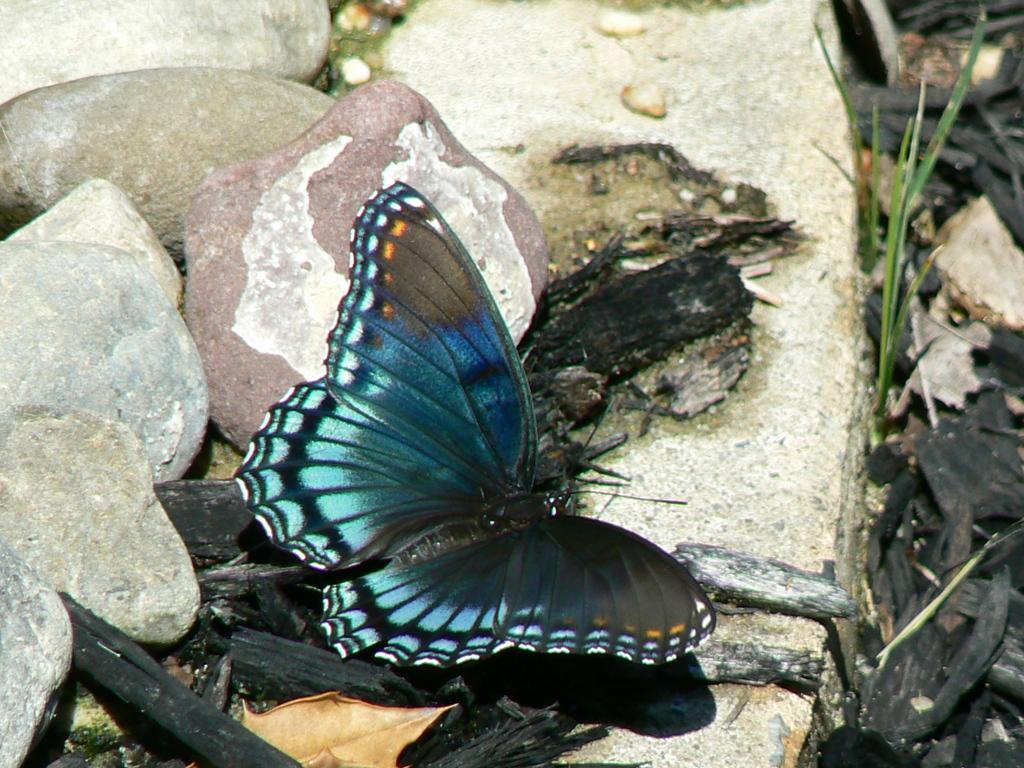Can you describe this image briefly? In this image I can see blue colour butterfly, grass and few black colour things. I can also see few stones over here. 